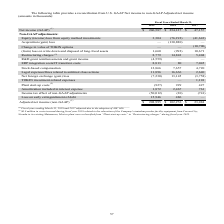According to Kemet Corporation's financial document, What was the net income (GAAP) in 2019? According to the financial document, 206,587 (in thousands). The relevant text states: "Net income (GAAP) (1) $ 206,587 $ 254,127 $ 47,157..." Also, What was the Acquisition (gain) loss in 2018? According to the financial document, (130,880) (in thousands). The relevant text states: "Acquisition (gain) loss — (130,880) —..." Also, What were the restructuring charges in 2017? According to the financial document, 5,404 (in thousands). The relevant text states: "Restructuring charges (2) 8,779 14,843 5,404..." Also, How many years did restructuring charges exceed $10,000 thousand? Based on the analysis, there are 1 instances. The counting process: 2018. Also, can you calculate: What was the change in the Legal expenses/fines related to antitrust class actions between 2017 and 2018? Based on the calculation: 16,636-2,640, the result is 13996 (in thousands). This is based on the information: "related to antitrust class actions 11,896 16,636 2,640 s/fines related to antitrust class actions 11,896 16,636 2,640..." The key data points involved are: 16,636, 2,640. Also, can you calculate: What was the percentage change in the Amortization included in interest expense between 2017 and 2019? To answer this question, I need to perform calculations using the financial data. The calculation is: (1,872-761)/761, which equals 145.99 (percentage). This is based on the information: "Amortization included in interest expense 1,872 2,467 761 tization included in interest expense 1,872 2,467 761..." The key data points involved are: 1,872, 761. 